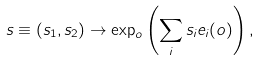Convert formula to latex. <formula><loc_0><loc_0><loc_500><loc_500>s \equiv ( s _ { 1 } , s _ { 2 } ) \rightarrow \exp _ { o } \left ( \sum _ { i } s _ { i } e _ { i } ( o ) \right ) ,</formula> 